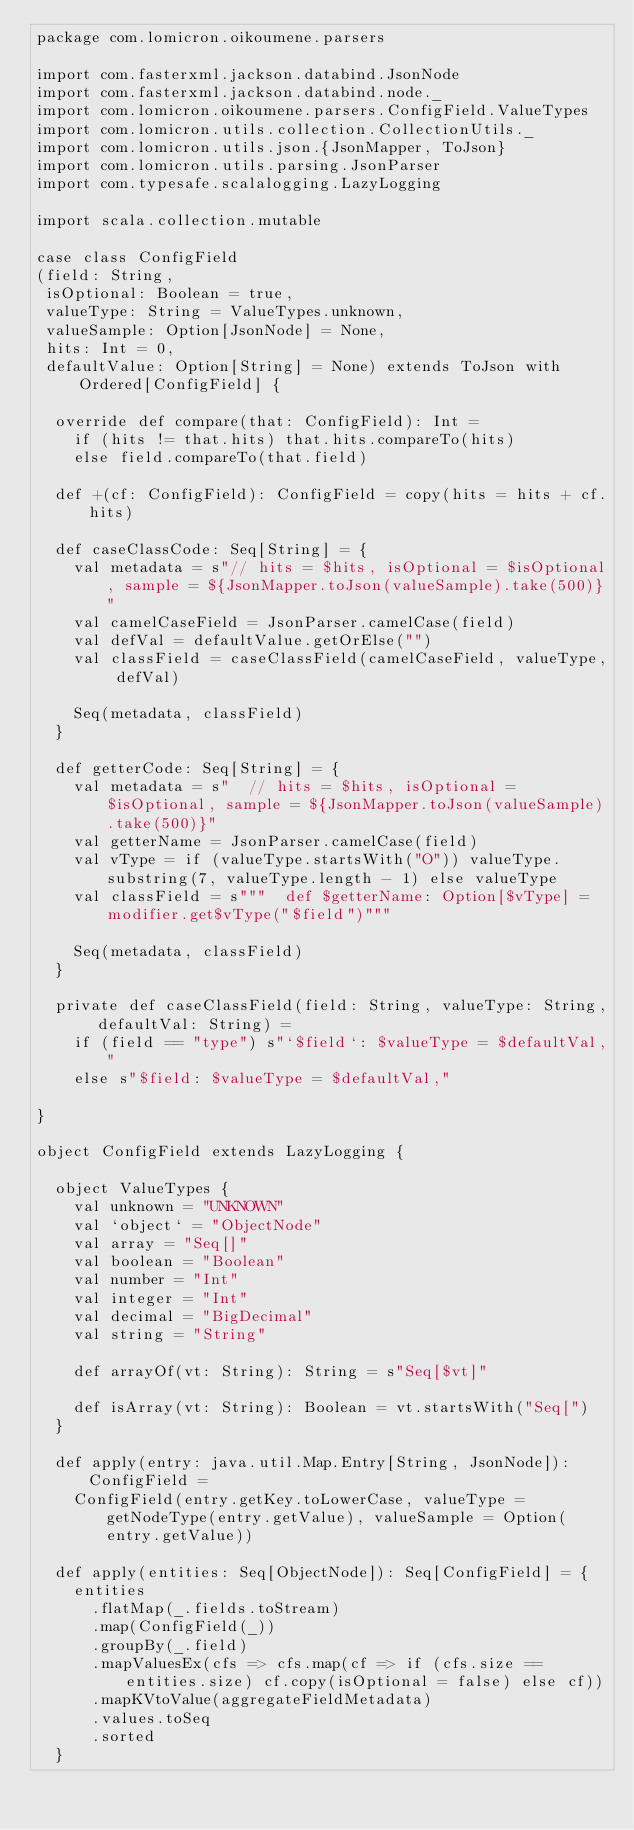<code> <loc_0><loc_0><loc_500><loc_500><_Scala_>package com.lomicron.oikoumene.parsers

import com.fasterxml.jackson.databind.JsonNode
import com.fasterxml.jackson.databind.node._
import com.lomicron.oikoumene.parsers.ConfigField.ValueTypes
import com.lomicron.utils.collection.CollectionUtils._
import com.lomicron.utils.json.{JsonMapper, ToJson}
import com.lomicron.utils.parsing.JsonParser
import com.typesafe.scalalogging.LazyLogging

import scala.collection.mutable

case class ConfigField
(field: String,
 isOptional: Boolean = true,
 valueType: String = ValueTypes.unknown,
 valueSample: Option[JsonNode] = None,
 hits: Int = 0,
 defaultValue: Option[String] = None) extends ToJson with Ordered[ConfigField] {

  override def compare(that: ConfigField): Int =
    if (hits != that.hits) that.hits.compareTo(hits)
    else field.compareTo(that.field)

  def +(cf: ConfigField): ConfigField = copy(hits = hits + cf.hits)

  def caseClassCode: Seq[String] = {
    val metadata = s"// hits = $hits, isOptional = $isOptional, sample = ${JsonMapper.toJson(valueSample).take(500)}"
    val camelCaseField = JsonParser.camelCase(field)
    val defVal = defaultValue.getOrElse("")
    val classField = caseClassField(camelCaseField, valueType, defVal)

    Seq(metadata, classField)
  }

  def getterCode: Seq[String] = {
    val metadata = s"  // hits = $hits, isOptional = $isOptional, sample = ${JsonMapper.toJson(valueSample).take(500)}"
    val getterName = JsonParser.camelCase(field)
    val vType = if (valueType.startsWith("O")) valueType.substring(7, valueType.length - 1) else valueType
    val classField = s"""  def $getterName: Option[$vType] = modifier.get$vType("$field")"""

    Seq(metadata, classField)
  }

  private def caseClassField(field: String, valueType: String, defaultVal: String) =
    if (field == "type") s"`$field`: $valueType = $defaultVal,"
    else s"$field: $valueType = $defaultVal,"

}

object ConfigField extends LazyLogging {

  object ValueTypes {
    val unknown = "UNKNOWN"
    val `object` = "ObjectNode"
    val array = "Seq[]"
    val boolean = "Boolean"
    val number = "Int"
    val integer = "Int"
    val decimal = "BigDecimal"
    val string = "String"

    def arrayOf(vt: String): String = s"Seq[$vt]"

    def isArray(vt: String): Boolean = vt.startsWith("Seq[")
  }

  def apply(entry: java.util.Map.Entry[String, JsonNode]): ConfigField =
    ConfigField(entry.getKey.toLowerCase, valueType = getNodeType(entry.getValue), valueSample = Option(entry.getValue))

  def apply(entities: Seq[ObjectNode]): Seq[ConfigField] = {
    entities
      .flatMap(_.fields.toStream)
      .map(ConfigField(_))
      .groupBy(_.field)
      .mapValuesEx(cfs => cfs.map(cf => if (cfs.size == entities.size) cf.copy(isOptional = false) else cf))
      .mapKVtoValue(aggregateFieldMetadata)
      .values.toSeq
      .sorted
  }
</code> 